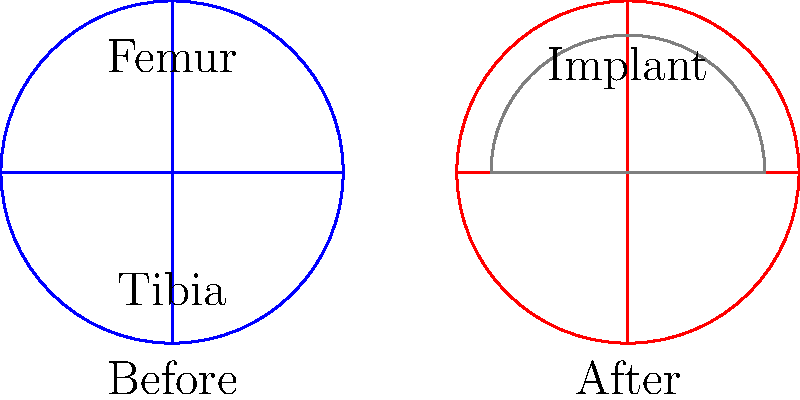In a total knee replacement surgery, what is the primary biomechanical advantage of using a metal-on-plastic articulating surface compared to the natural knee joint? To understand the biomechanical advantage of a metal-on-plastic articulating surface in total knee replacement, let's consider the following steps:

1. Natural knee joint:
   - Consists of cartilage-on-cartilage articulation
   - Provides low friction but is susceptible to wear and tear

2. Metal-on-plastic implant:
   - Typically uses a cobalt-chromium alloy for the femoral component
   - Uses ultra-high-molecular-weight polyethylene (UHMWPE) for the tibial component

3. Biomechanical advantages:
   a. Reduced friction:
      - The metal-on-plastic interface has a lower coefficient of friction than cartilage-on-cartilage
      - This results in smoother movement and less wear over time

   b. Increased durability:
      - Metal and UHMWPE are more resistant to wear than natural cartilage
      - This leads to a longer-lasting joint replacement

   c. Load distribution:
      - The implant materials can be designed to distribute load more evenly across the joint
      - This reduces stress concentrations and potential failure points

   d. Customization:
      - Implant geometry can be optimized for individual patient anatomy
      - This allows for better joint kinematics and range of motion

4. Overall impact:
   - The primary biomechanical advantage is the combination of reduced friction and increased durability
   - This results in a longer-lasting joint replacement with improved function and reduced pain for the patient

The metal-on-plastic articulating surface provides a more wear-resistant and lower friction interface compared to the natural knee joint, leading to improved longevity and performance of the total knee replacement.
Answer: Reduced friction and increased durability 